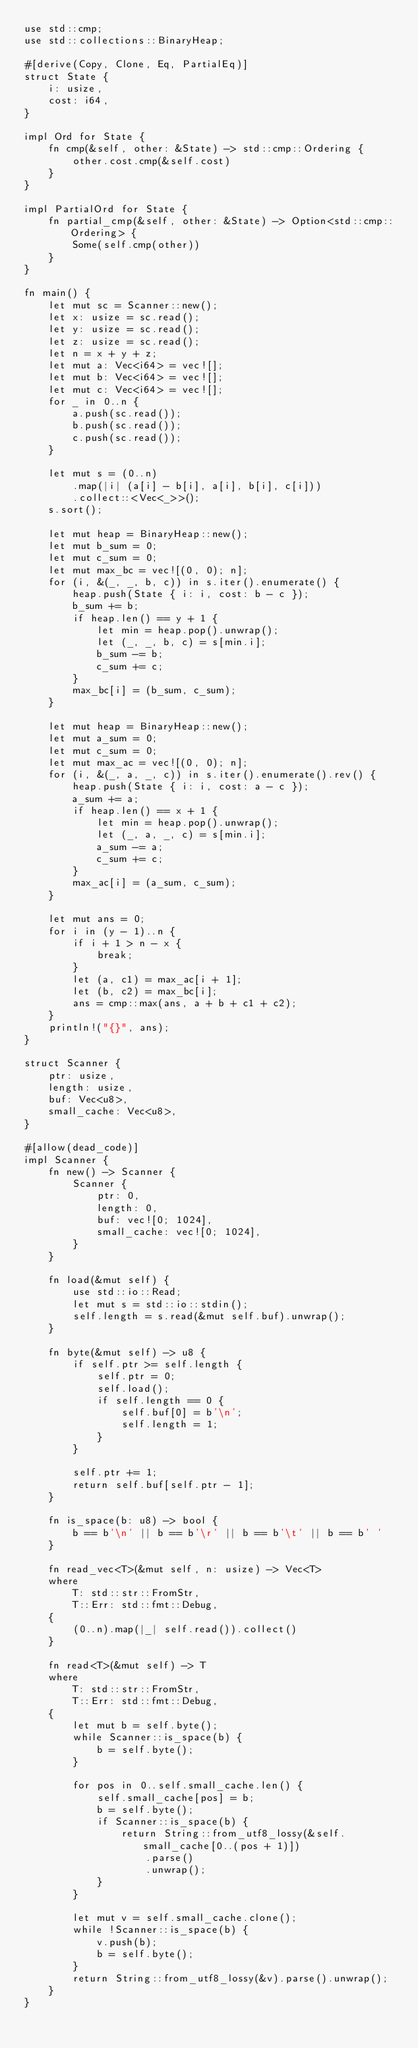<code> <loc_0><loc_0><loc_500><loc_500><_Rust_>use std::cmp;
use std::collections::BinaryHeap;

#[derive(Copy, Clone, Eq, PartialEq)]
struct State {
    i: usize,
    cost: i64,
}

impl Ord for State {
    fn cmp(&self, other: &State) -> std::cmp::Ordering {
        other.cost.cmp(&self.cost)
    }
}

impl PartialOrd for State {
    fn partial_cmp(&self, other: &State) -> Option<std::cmp::Ordering> {
        Some(self.cmp(other))
    }
}

fn main() {
    let mut sc = Scanner::new();
    let x: usize = sc.read();
    let y: usize = sc.read();
    let z: usize = sc.read();
    let n = x + y + z;
    let mut a: Vec<i64> = vec![];
    let mut b: Vec<i64> = vec![];
    let mut c: Vec<i64> = vec![];
    for _ in 0..n {
        a.push(sc.read());
        b.push(sc.read());
        c.push(sc.read());
    }

    let mut s = (0..n)
        .map(|i| (a[i] - b[i], a[i], b[i], c[i]))
        .collect::<Vec<_>>();
    s.sort();

    let mut heap = BinaryHeap::new();
    let mut b_sum = 0;
    let mut c_sum = 0;
    let mut max_bc = vec![(0, 0); n];
    for (i, &(_, _, b, c)) in s.iter().enumerate() {
        heap.push(State { i: i, cost: b - c });
        b_sum += b;
        if heap.len() == y + 1 {
            let min = heap.pop().unwrap();
            let (_, _, b, c) = s[min.i];
            b_sum -= b;
            c_sum += c;
        }
        max_bc[i] = (b_sum, c_sum);
    }

    let mut heap = BinaryHeap::new();
    let mut a_sum = 0;
    let mut c_sum = 0;
    let mut max_ac = vec![(0, 0); n];
    for (i, &(_, a, _, c)) in s.iter().enumerate().rev() {
        heap.push(State { i: i, cost: a - c });
        a_sum += a;
        if heap.len() == x + 1 {
            let min = heap.pop().unwrap();
            let (_, a, _, c) = s[min.i];
            a_sum -= a;
            c_sum += c;
        }
        max_ac[i] = (a_sum, c_sum);
    }

    let mut ans = 0;
    for i in (y - 1)..n {
        if i + 1 > n - x {
            break;
        }
        let (a, c1) = max_ac[i + 1];
        let (b, c2) = max_bc[i];
        ans = cmp::max(ans, a + b + c1 + c2);
    }
    println!("{}", ans);
}

struct Scanner {
    ptr: usize,
    length: usize,
    buf: Vec<u8>,
    small_cache: Vec<u8>,
}

#[allow(dead_code)]
impl Scanner {
    fn new() -> Scanner {
        Scanner {
            ptr: 0,
            length: 0,
            buf: vec![0; 1024],
            small_cache: vec![0; 1024],
        }
    }

    fn load(&mut self) {
        use std::io::Read;
        let mut s = std::io::stdin();
        self.length = s.read(&mut self.buf).unwrap();
    }

    fn byte(&mut self) -> u8 {
        if self.ptr >= self.length {
            self.ptr = 0;
            self.load();
            if self.length == 0 {
                self.buf[0] = b'\n';
                self.length = 1;
            }
        }

        self.ptr += 1;
        return self.buf[self.ptr - 1];
    }

    fn is_space(b: u8) -> bool {
        b == b'\n' || b == b'\r' || b == b'\t' || b == b' '
    }

    fn read_vec<T>(&mut self, n: usize) -> Vec<T>
    where
        T: std::str::FromStr,
        T::Err: std::fmt::Debug,
    {
        (0..n).map(|_| self.read()).collect()
    }

    fn read<T>(&mut self) -> T
    where
        T: std::str::FromStr,
        T::Err: std::fmt::Debug,
    {
        let mut b = self.byte();
        while Scanner::is_space(b) {
            b = self.byte();
        }

        for pos in 0..self.small_cache.len() {
            self.small_cache[pos] = b;
            b = self.byte();
            if Scanner::is_space(b) {
                return String::from_utf8_lossy(&self.small_cache[0..(pos + 1)])
                    .parse()
                    .unwrap();
            }
        }

        let mut v = self.small_cache.clone();
        while !Scanner::is_space(b) {
            v.push(b);
            b = self.byte();
        }
        return String::from_utf8_lossy(&v).parse().unwrap();
    }
}
</code> 